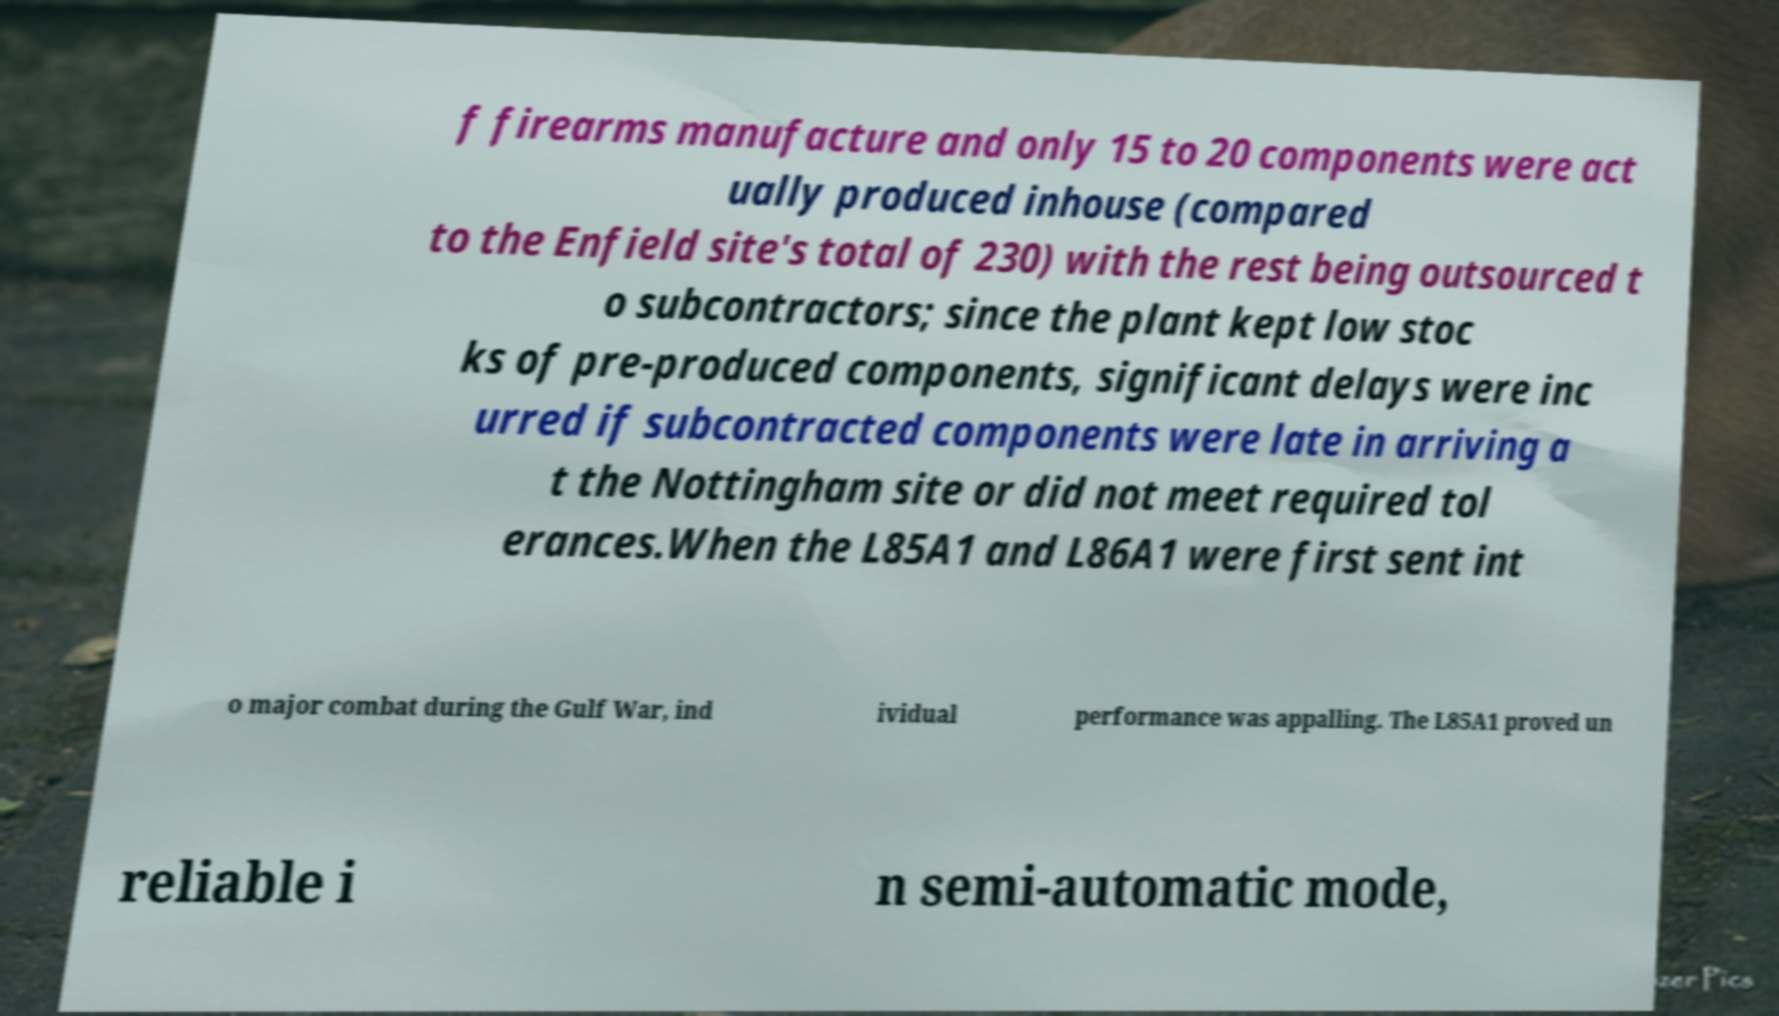What messages or text are displayed in this image? I need them in a readable, typed format. f firearms manufacture and only 15 to 20 components were act ually produced inhouse (compared to the Enfield site's total of 230) with the rest being outsourced t o subcontractors; since the plant kept low stoc ks of pre-produced components, significant delays were inc urred if subcontracted components were late in arriving a t the Nottingham site or did not meet required tol erances.When the L85A1 and L86A1 were first sent int o major combat during the Gulf War, ind ividual performance was appalling. The L85A1 proved un reliable i n semi-automatic mode, 